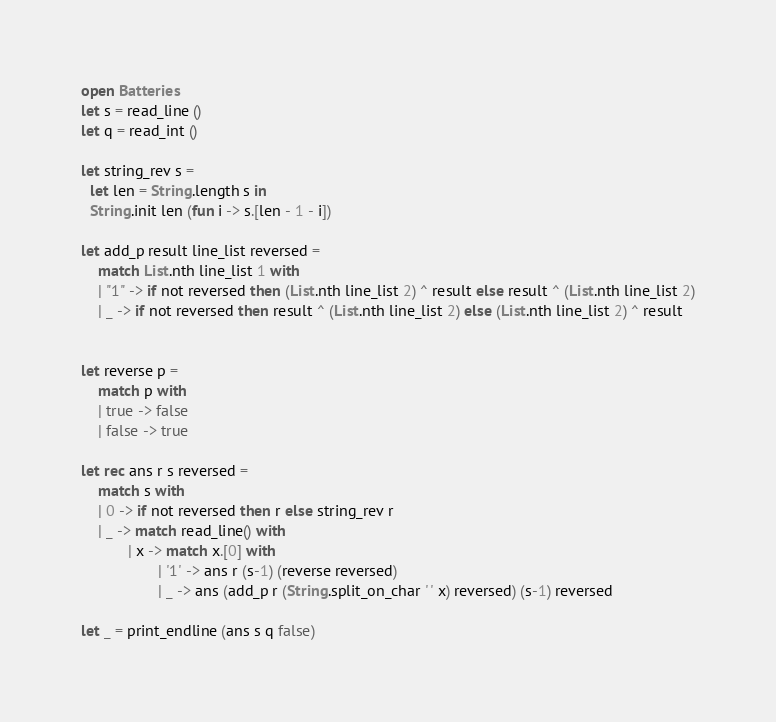<code> <loc_0><loc_0><loc_500><loc_500><_OCaml_>open Batteries
let s = read_line ()
let q = read_int ()

let string_rev s =
  let len = String.length s in
  String.init len (fun i -> s.[len - 1 - i])

let add_p result line_list reversed =
    match List.nth line_list 1 with
    | "1" -> if not reversed then (List.nth line_list 2) ^ result else result ^ (List.nth line_list 2)
    | _ -> if not reversed then result ^ (List.nth line_list 2) else (List.nth line_list 2) ^ result


let reverse p =
    match p with
    | true -> false
    | false -> true

let rec ans r s reversed = 
    match s with
    | 0 -> if not reversed then r else string_rev r
    | _ -> match read_line() with
           | x -> match x.[0] with
                  | '1' -> ans r (s-1) (reverse reversed)
                  | _ -> ans (add_p r (String.split_on_char ' ' x) reversed) (s-1) reversed

let _ = print_endline (ans s q false)
</code> 